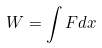<formula> <loc_0><loc_0><loc_500><loc_500>W = \int F d x</formula> 